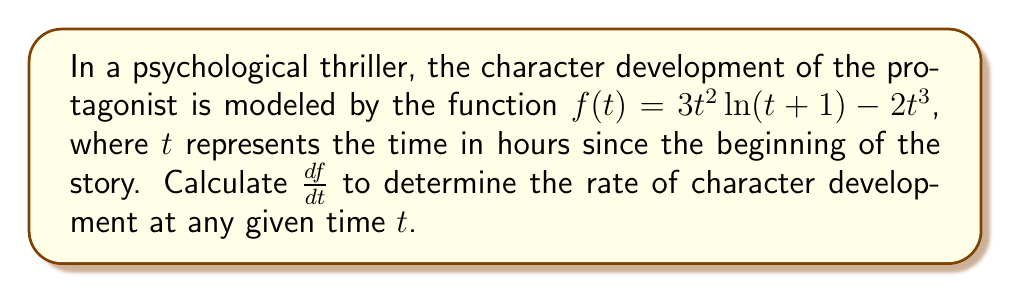Could you help me with this problem? To find the derivative of $f(t)$, we need to apply the product rule and the chain rule:

1) First, let's break down the function into two parts:
   $u(t) = 3t^2$ and $v(t) = \ln(t+1) - \frac{2}{3}t$

   So, $f(t) = u(t)v(t)$

2) Using the product rule, we get:
   $\frac{df}{dt} = u'(t)v(t) + u(t)v'(t)$

3) Let's calculate $u'(t)$:
   $u'(t) = 6t$

4) Now, let's calculate $v'(t)$:
   $v'(t) = \frac{1}{t+1} - \frac{2}{3}$
   
   This is because $\frac{d}{dt}\ln(t+1) = \frac{1}{t+1}$ and $\frac{d}{dt}(-\frac{2}{3}t) = -\frac{2}{3}$

5) Substituting these back into the product rule equation:
   $\frac{df}{dt} = 6t[\ln(t+1) - \frac{2}{3}t] + 3t^2[\frac{1}{t+1} - \frac{2}{3}]$

6) Simplifying:
   $\frac{df}{dt} = 6t\ln(t+1) - 4t^2 + \frac{3t^2}{t+1} - 2t^2$

7) Combining like terms:
   $\frac{df}{dt} = 6t\ln(t+1) - 6t^2 + \frac{3t^2}{t+1}$

This gives us the rate of character development at any time $t$.
Answer: $$\frac{df}{dt} = 6t\ln(t+1) - 6t^2 + \frac{3t^2}{t+1}$$ 